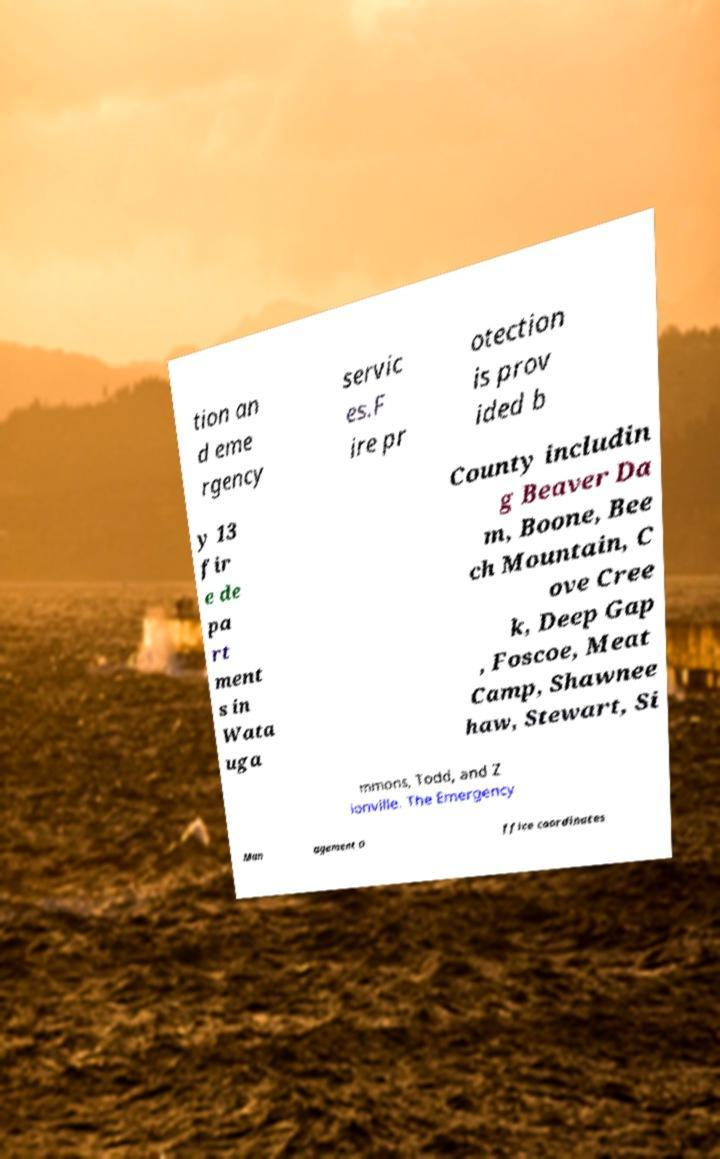For documentation purposes, I need the text within this image transcribed. Could you provide that? tion an d eme rgency servic es.F ire pr otection is prov ided b y 13 fir e de pa rt ment s in Wata uga County includin g Beaver Da m, Boone, Bee ch Mountain, C ove Cree k, Deep Gap , Foscoe, Meat Camp, Shawnee haw, Stewart, Si mmons, Todd, and Z ionville. The Emergency Man agement O ffice coordinates 